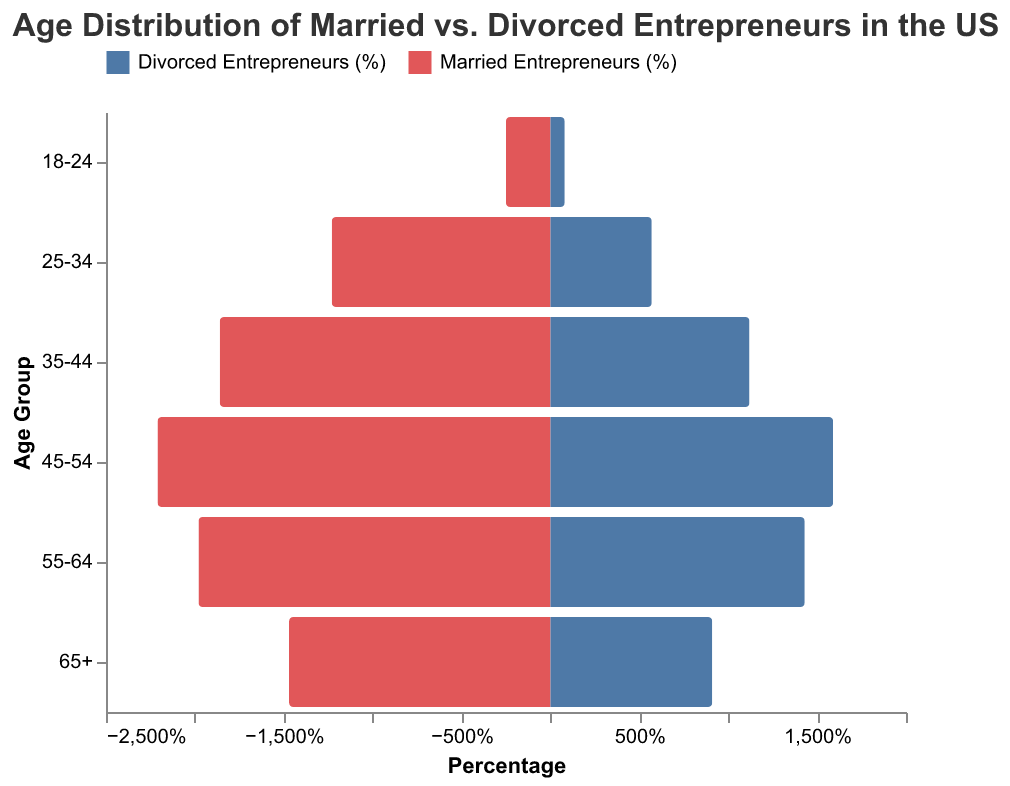What is the title of the figure? The title is usually placed at the top center of the figure and provides an overview of what the data represents. The title says "Age Distribution of Married vs. Divorced Entrepreneurs in the US".
Answer: Age Distribution of Married vs. Divorced Entrepreneurs in the US How does the percentage of married entrepreneurs aged 25-34 compare to divorced entrepreneurs in the same age group? To answer this, look at the bars corresponding to the 25-34 age group. The bar for married entrepreneurs is longer than the one for divorced entrepreneurs, indicating a higher percentage.
Answer: Higher for married entrepreneurs Which age group shows the largest difference between married and divorced entrepreneurs? Examine each age group by comparing the length of the bars (absolute difference in percentages) for married versus divorced entrepreneurs. The 45-54 age group shows the largest difference (22.1% - 15.9% = 6.2%).
Answer: 45-54 What percentage of divorced entrepreneurs are in the 55-64 age group? Locate the bar labeled '55-64' for divorced entrepreneurs and read its length. It indicates 14.3%.
Answer: 14.3% Which age group contains the most significant proportion of married entrepreneurs? Look for the longest bar among those representing married entrepreneurs. The 45-54 age group has the longest bar at 22.1%.
Answer: 45-54 By how much does the percentage of married entrepreneurs aged 35-44 exceed that of divorced entrepreneurs in the same age group? Calculate the difference by subtracting the percentage of divorced (11.2%) from married (18.6%) for the 35-44 age group. The difference is 18.6% - 11.2% = 7.4%.
Answer: 7.4% What is the age distribution trend for married entrepreneurs from the youngest to the oldest age group? Observe the pattern in the lengths of bars representing married entrepreneurs from the youngest to the oldest age group. The trend shows percentages increasing from 18-24 to 45-54, then slightly decreasing for older age groups.
Answer: Increases up to 45-54, then decreases Which age group of entrepreneurs shows the smallest absolute percentage difference between married and divorced statuses? Identify the smallest difference by comparing the bars among all age groups. The 18-24 age group has the smallest difference (2.5% - 0.8% = 1.7%).
Answer: 18-24 Summarize the overall age distribution for divorced entrepreneurs. Overall, divorced entrepreneurs are less frequent across all age groups compared to married entrepreneurs. The percentages gradually increase from 18-24 to 45-54, then decrease in older age groups.
Answer: Gradual increase to 45-54, then decrease In which age group do the percentages of married and divorced entrepreneurs show the closest values? Compare the bars to find where they are closest in length. The age group 55-64 has percentages of 19.8% (married) and 14.3% (divorced), a difference of 5.5% which is relatively close compared to other groups.
Answer: 55-64 